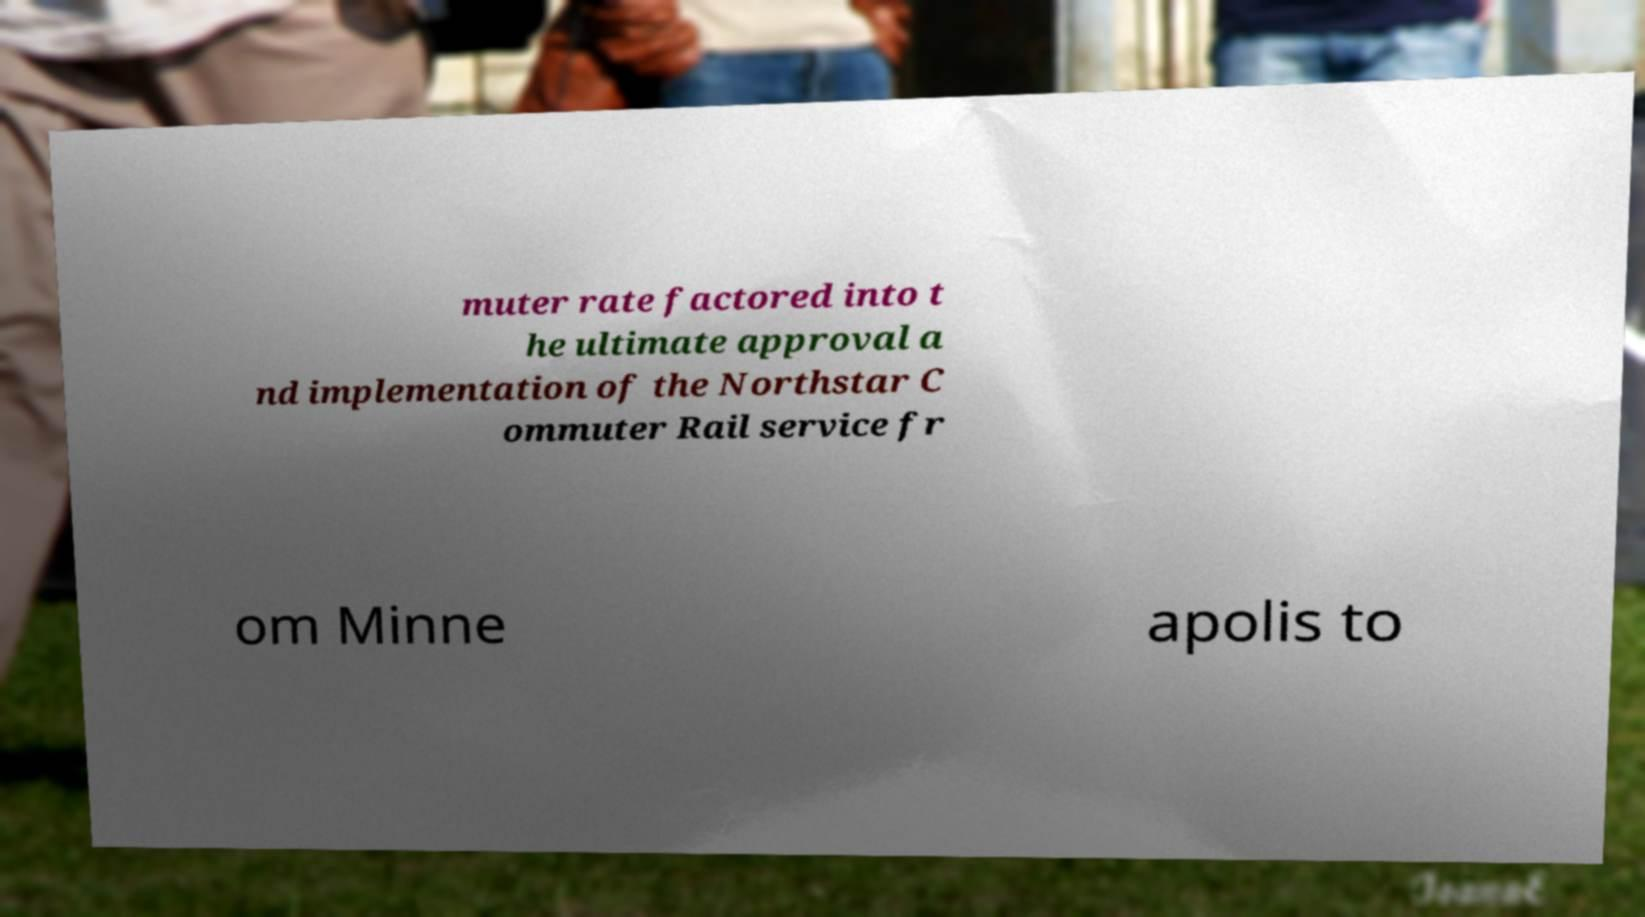For documentation purposes, I need the text within this image transcribed. Could you provide that? muter rate factored into t he ultimate approval a nd implementation of the Northstar C ommuter Rail service fr om Minne apolis to 